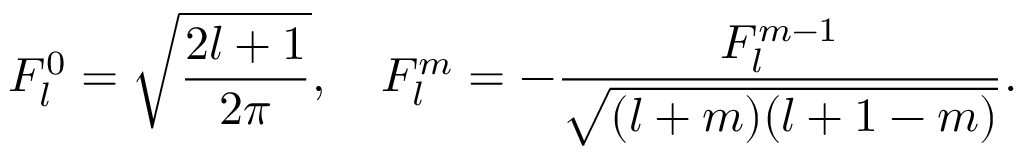Convert formula to latex. <formula><loc_0><loc_0><loc_500><loc_500>F _ { l } ^ { 0 } = \sqrt { \frac { 2 l + 1 } { 2 \pi } } , \quad F _ { l } ^ { m } = - \frac { F _ { l } ^ { m - 1 } } { \sqrt { ( l + m ) ( l + 1 - m ) } } .</formula> 